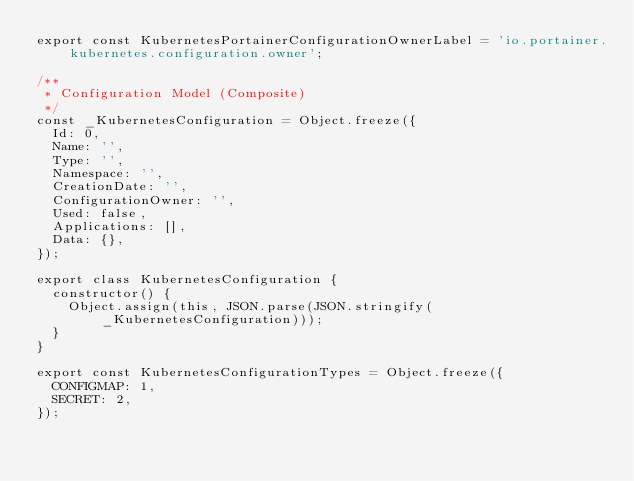<code> <loc_0><loc_0><loc_500><loc_500><_JavaScript_>export const KubernetesPortainerConfigurationOwnerLabel = 'io.portainer.kubernetes.configuration.owner';

/**
 * Configuration Model (Composite)
 */
const _KubernetesConfiguration = Object.freeze({
  Id: 0,
  Name: '',
  Type: '',
  Namespace: '',
  CreationDate: '',
  ConfigurationOwner: '',
  Used: false,
  Applications: [],
  Data: {},
});

export class KubernetesConfiguration {
  constructor() {
    Object.assign(this, JSON.parse(JSON.stringify(_KubernetesConfiguration)));
  }
}

export const KubernetesConfigurationTypes = Object.freeze({
  CONFIGMAP: 1,
  SECRET: 2,
});
</code> 